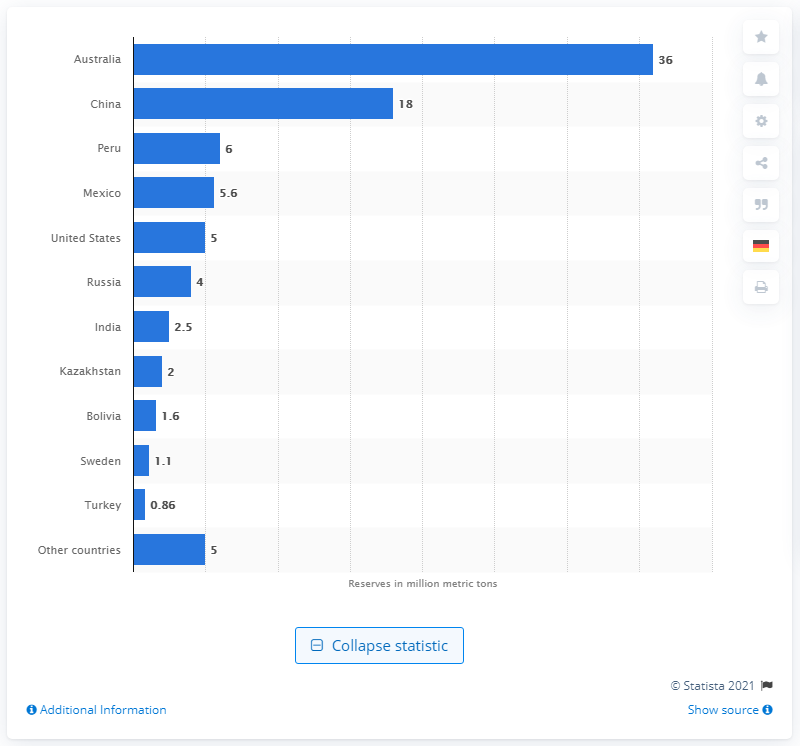Identify some key points in this picture. In 2020, the amount of lead stored in Australia was approximately 36 metric tons. In 2020, Australia had 36 metric tons of lead. 